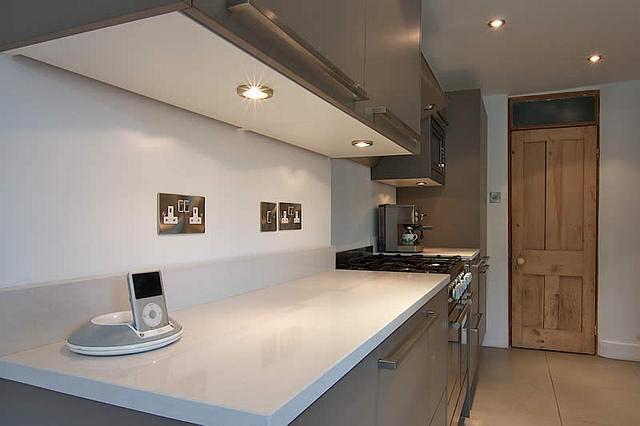How many microwaves are there?
Give a very brief answer. 1. 